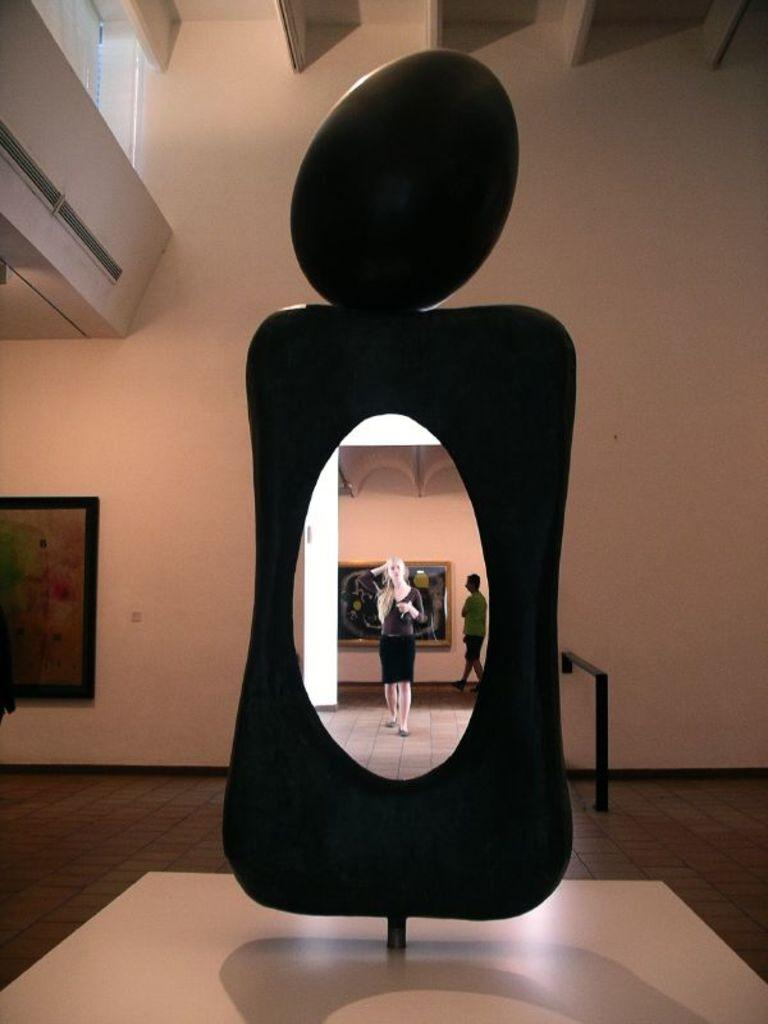What is present in the background of the image? There is a wall in the image. Can you describe the people in the image? There are people in the image. What type of decorative items can be seen in the image? There are photo frames in the image. What type of light can be seen emanating from the photo frames in the image? There is no light emanating from the photo frames in the image; they are simply decorative items. What force is being applied to the people in the image? There is no force being applied to the people in the image; they are standing or sitting normally. 